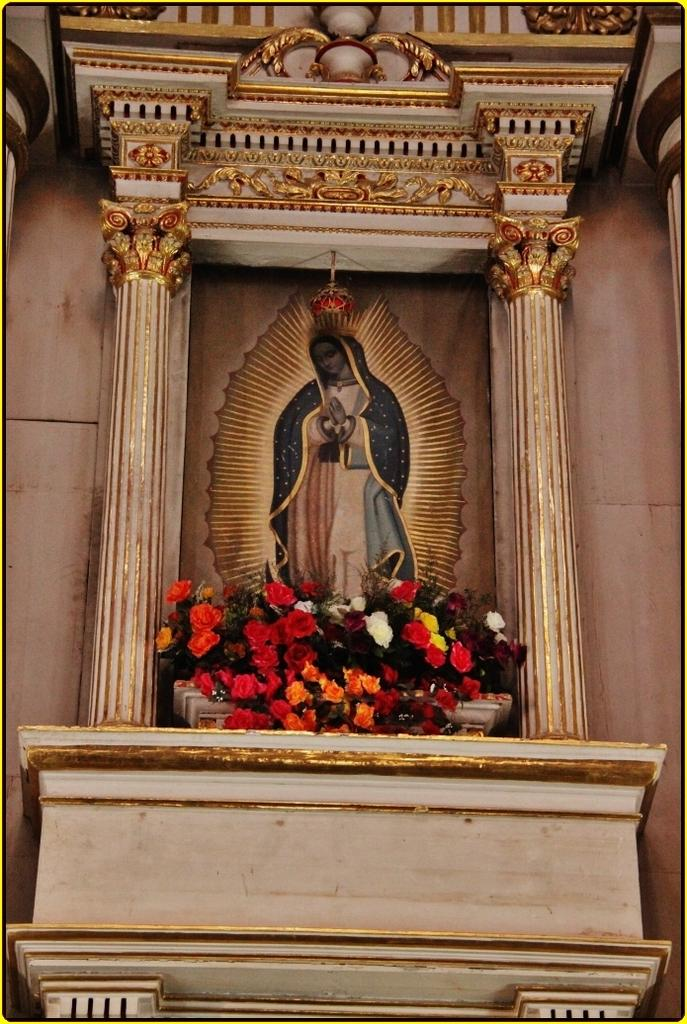What is the main subject of the painting in the image? The main subject of the painting in the image is a woman. What architectural elements are present around the painting? There are two pillars around the painting. What other decorative elements can be seen in the image? There are flowers and beautiful carvings above the painting. What type of cushion is placed on the baby's chair in the image? There is no baby or chair present in the image, so it is not possible to answer that question. 